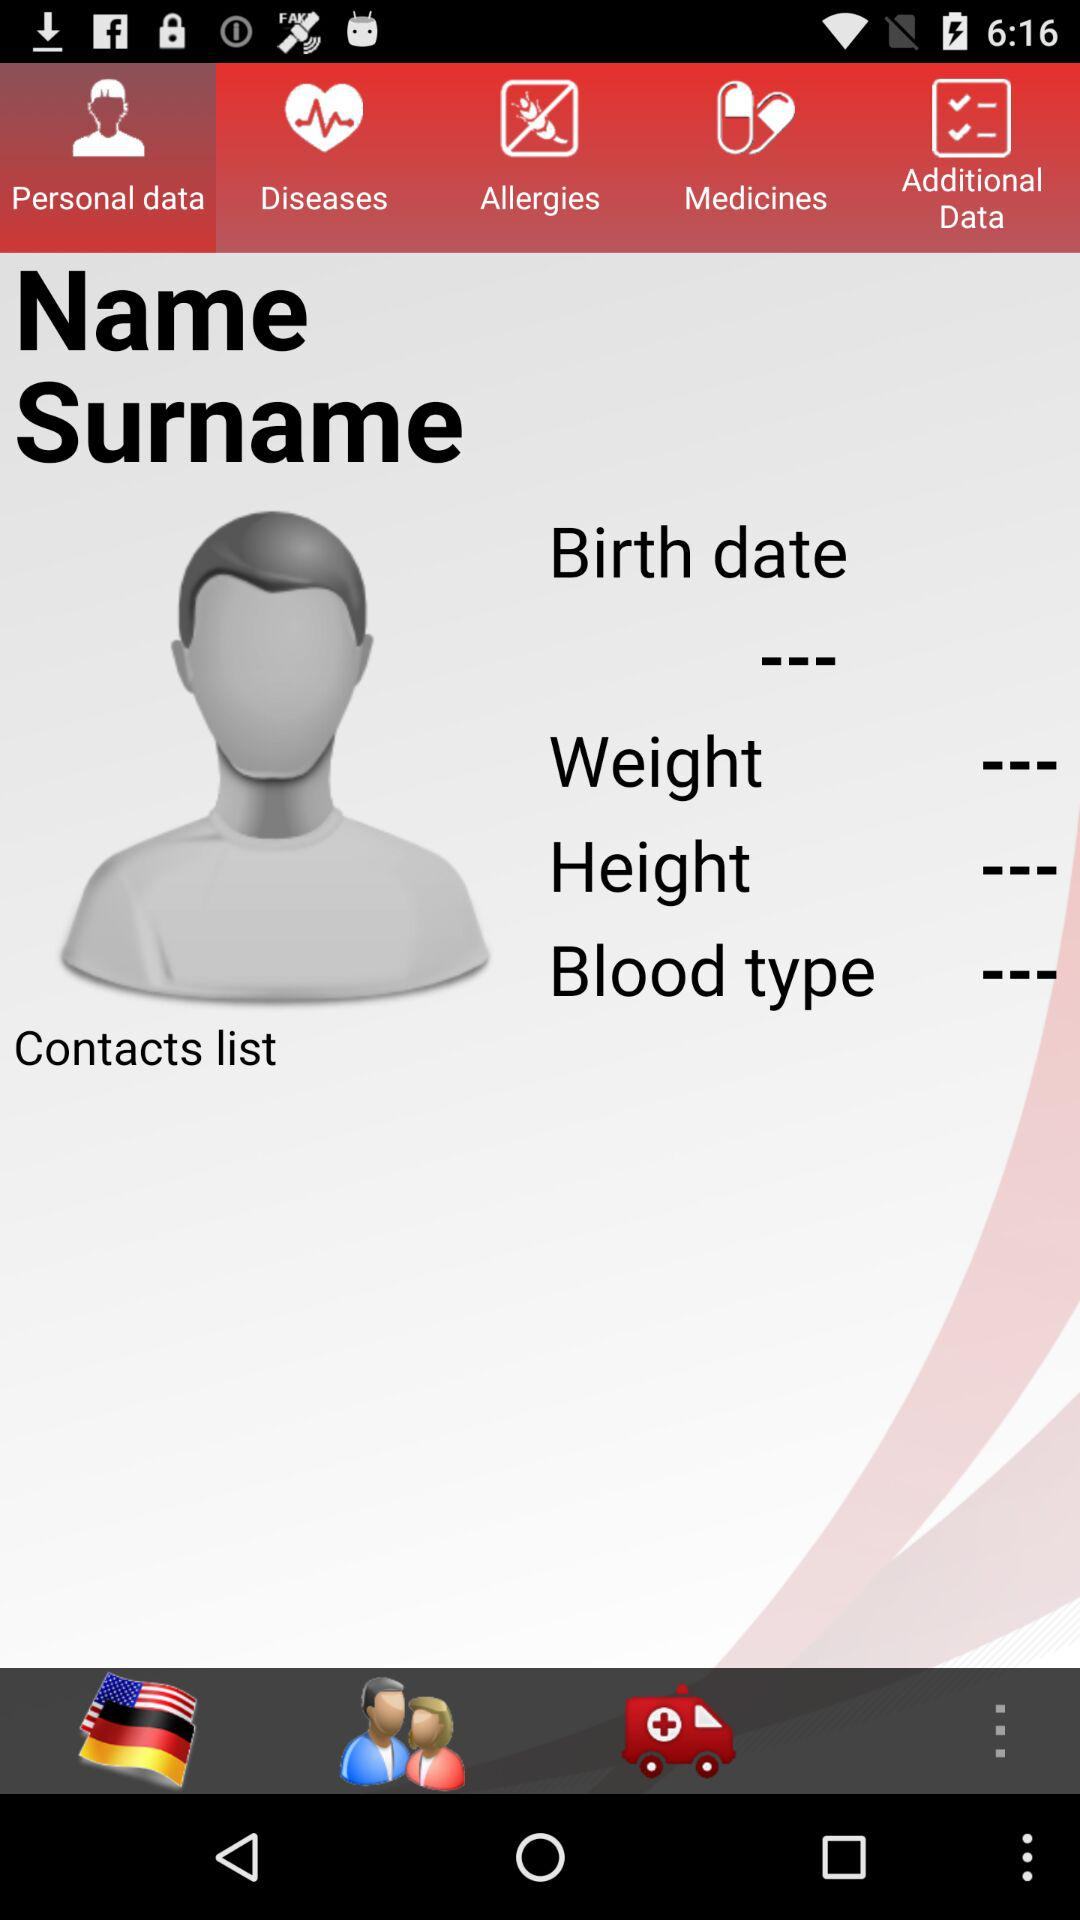Which tab is selected? The selected tab is "Personal data". 